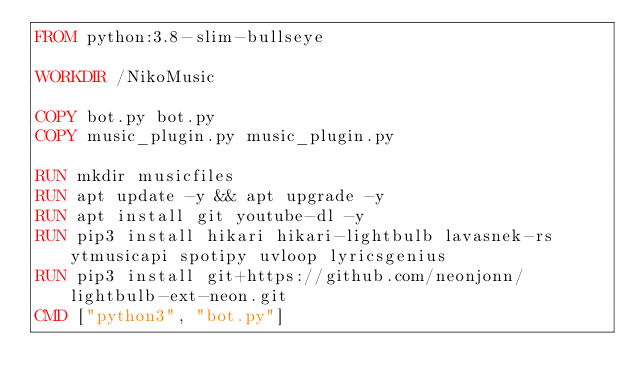Convert code to text. <code><loc_0><loc_0><loc_500><loc_500><_Dockerfile_>FROM python:3.8-slim-bullseye

WORKDIR /NikoMusic

COPY bot.py bot.py
COPY music_plugin.py music_plugin.py

RUN mkdir musicfiles
RUN apt update -y && apt upgrade -y
RUN apt install git youtube-dl -y
RUN pip3 install hikari hikari-lightbulb lavasnek-rs ytmusicapi spotipy uvloop lyricsgenius 
RUN pip3 install git+https://github.com/neonjonn/lightbulb-ext-neon.git
CMD ["python3", "bot.py"]
</code> 